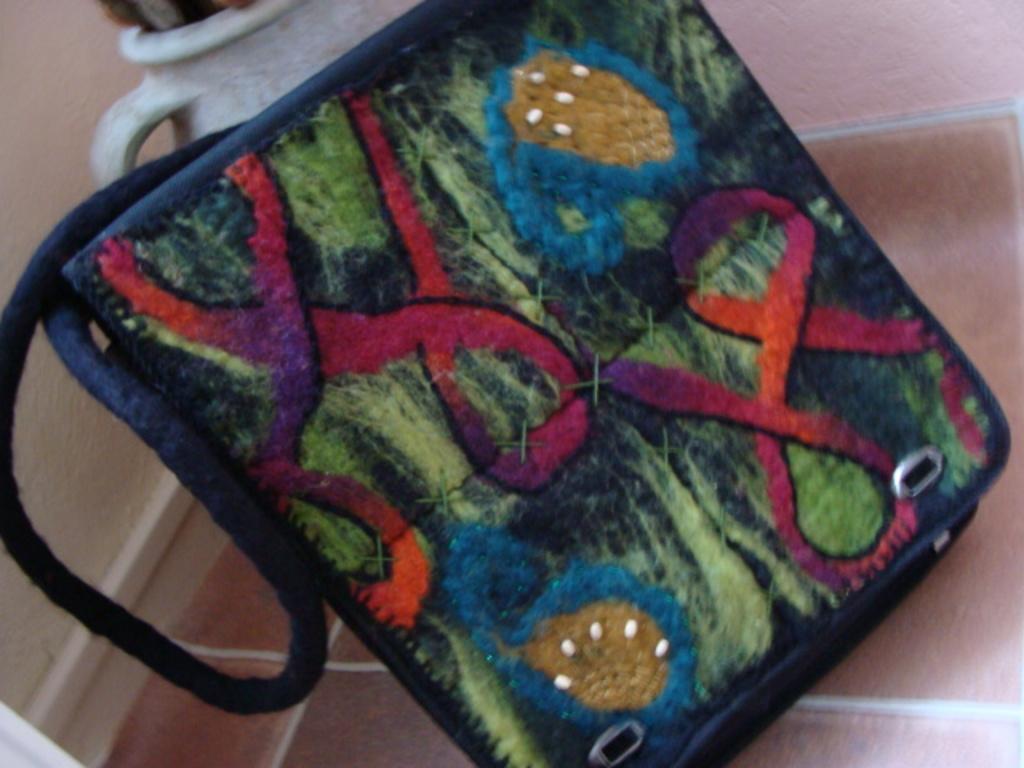Can you describe this image briefly? There is a decorative handbag on a floor. In the background, there is pot and wall. 